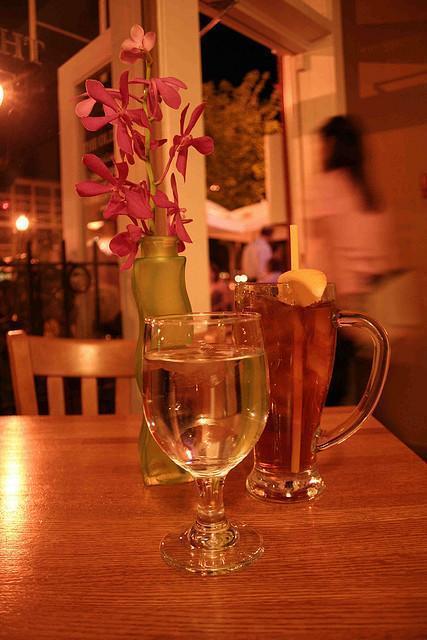How many drinks are there?
Give a very brief answer. 2. How many cups are in the picture?
Give a very brief answer. 1. How many dining tables can you see?
Give a very brief answer. 1. How many chairs can be seen?
Give a very brief answer. 1. 